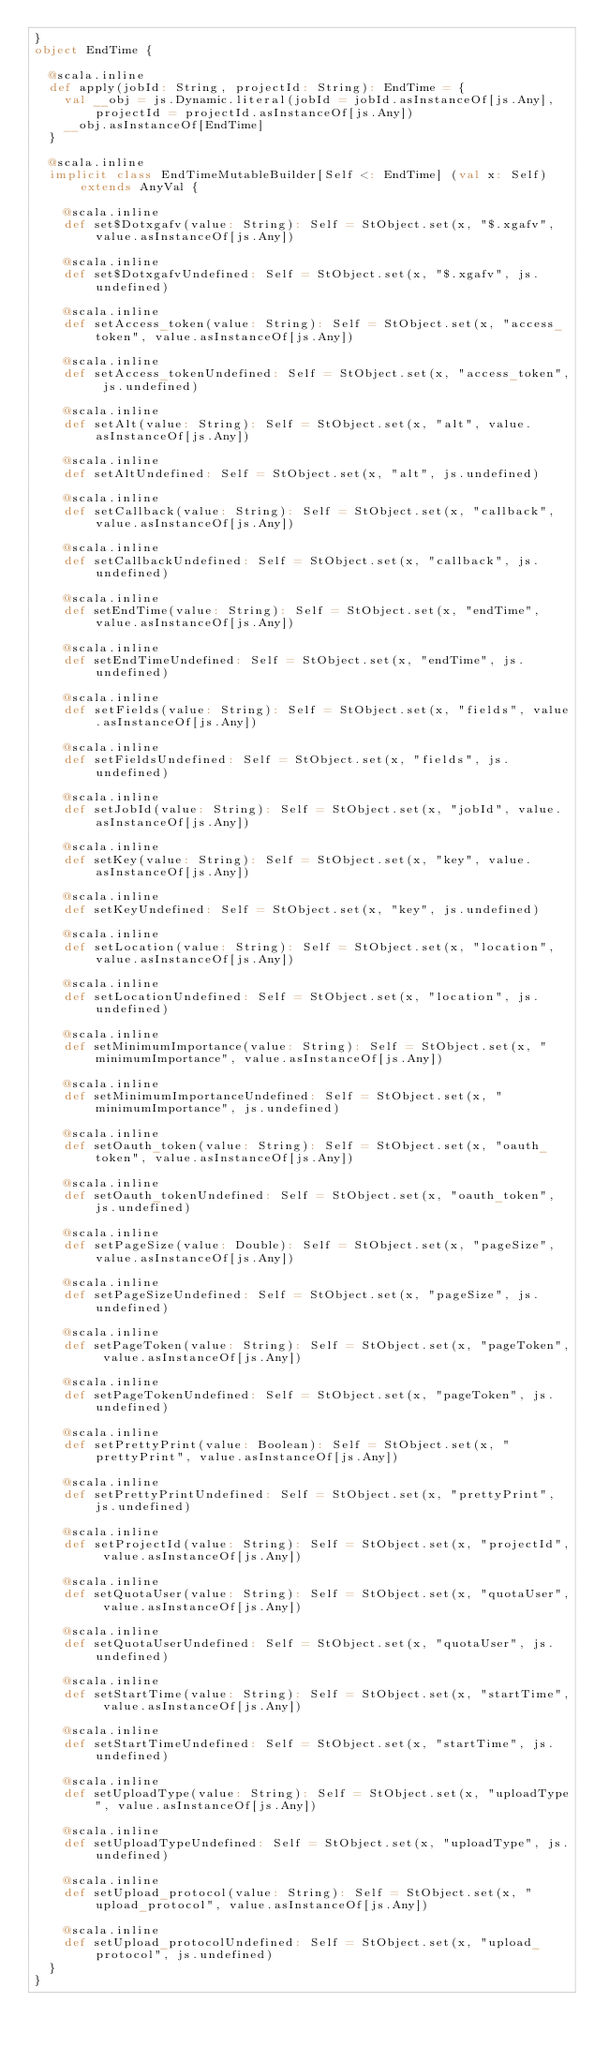<code> <loc_0><loc_0><loc_500><loc_500><_Scala_>}
object EndTime {
  
  @scala.inline
  def apply(jobId: String, projectId: String): EndTime = {
    val __obj = js.Dynamic.literal(jobId = jobId.asInstanceOf[js.Any], projectId = projectId.asInstanceOf[js.Any])
    __obj.asInstanceOf[EndTime]
  }
  
  @scala.inline
  implicit class EndTimeMutableBuilder[Self <: EndTime] (val x: Self) extends AnyVal {
    
    @scala.inline
    def set$Dotxgafv(value: String): Self = StObject.set(x, "$.xgafv", value.asInstanceOf[js.Any])
    
    @scala.inline
    def set$DotxgafvUndefined: Self = StObject.set(x, "$.xgafv", js.undefined)
    
    @scala.inline
    def setAccess_token(value: String): Self = StObject.set(x, "access_token", value.asInstanceOf[js.Any])
    
    @scala.inline
    def setAccess_tokenUndefined: Self = StObject.set(x, "access_token", js.undefined)
    
    @scala.inline
    def setAlt(value: String): Self = StObject.set(x, "alt", value.asInstanceOf[js.Any])
    
    @scala.inline
    def setAltUndefined: Self = StObject.set(x, "alt", js.undefined)
    
    @scala.inline
    def setCallback(value: String): Self = StObject.set(x, "callback", value.asInstanceOf[js.Any])
    
    @scala.inline
    def setCallbackUndefined: Self = StObject.set(x, "callback", js.undefined)
    
    @scala.inline
    def setEndTime(value: String): Self = StObject.set(x, "endTime", value.asInstanceOf[js.Any])
    
    @scala.inline
    def setEndTimeUndefined: Self = StObject.set(x, "endTime", js.undefined)
    
    @scala.inline
    def setFields(value: String): Self = StObject.set(x, "fields", value.asInstanceOf[js.Any])
    
    @scala.inline
    def setFieldsUndefined: Self = StObject.set(x, "fields", js.undefined)
    
    @scala.inline
    def setJobId(value: String): Self = StObject.set(x, "jobId", value.asInstanceOf[js.Any])
    
    @scala.inline
    def setKey(value: String): Self = StObject.set(x, "key", value.asInstanceOf[js.Any])
    
    @scala.inline
    def setKeyUndefined: Self = StObject.set(x, "key", js.undefined)
    
    @scala.inline
    def setLocation(value: String): Self = StObject.set(x, "location", value.asInstanceOf[js.Any])
    
    @scala.inline
    def setLocationUndefined: Self = StObject.set(x, "location", js.undefined)
    
    @scala.inline
    def setMinimumImportance(value: String): Self = StObject.set(x, "minimumImportance", value.asInstanceOf[js.Any])
    
    @scala.inline
    def setMinimumImportanceUndefined: Self = StObject.set(x, "minimumImportance", js.undefined)
    
    @scala.inline
    def setOauth_token(value: String): Self = StObject.set(x, "oauth_token", value.asInstanceOf[js.Any])
    
    @scala.inline
    def setOauth_tokenUndefined: Self = StObject.set(x, "oauth_token", js.undefined)
    
    @scala.inline
    def setPageSize(value: Double): Self = StObject.set(x, "pageSize", value.asInstanceOf[js.Any])
    
    @scala.inline
    def setPageSizeUndefined: Self = StObject.set(x, "pageSize", js.undefined)
    
    @scala.inline
    def setPageToken(value: String): Self = StObject.set(x, "pageToken", value.asInstanceOf[js.Any])
    
    @scala.inline
    def setPageTokenUndefined: Self = StObject.set(x, "pageToken", js.undefined)
    
    @scala.inline
    def setPrettyPrint(value: Boolean): Self = StObject.set(x, "prettyPrint", value.asInstanceOf[js.Any])
    
    @scala.inline
    def setPrettyPrintUndefined: Self = StObject.set(x, "prettyPrint", js.undefined)
    
    @scala.inline
    def setProjectId(value: String): Self = StObject.set(x, "projectId", value.asInstanceOf[js.Any])
    
    @scala.inline
    def setQuotaUser(value: String): Self = StObject.set(x, "quotaUser", value.asInstanceOf[js.Any])
    
    @scala.inline
    def setQuotaUserUndefined: Self = StObject.set(x, "quotaUser", js.undefined)
    
    @scala.inline
    def setStartTime(value: String): Self = StObject.set(x, "startTime", value.asInstanceOf[js.Any])
    
    @scala.inline
    def setStartTimeUndefined: Self = StObject.set(x, "startTime", js.undefined)
    
    @scala.inline
    def setUploadType(value: String): Self = StObject.set(x, "uploadType", value.asInstanceOf[js.Any])
    
    @scala.inline
    def setUploadTypeUndefined: Self = StObject.set(x, "uploadType", js.undefined)
    
    @scala.inline
    def setUpload_protocol(value: String): Self = StObject.set(x, "upload_protocol", value.asInstanceOf[js.Any])
    
    @scala.inline
    def setUpload_protocolUndefined: Self = StObject.set(x, "upload_protocol", js.undefined)
  }
}
</code> 